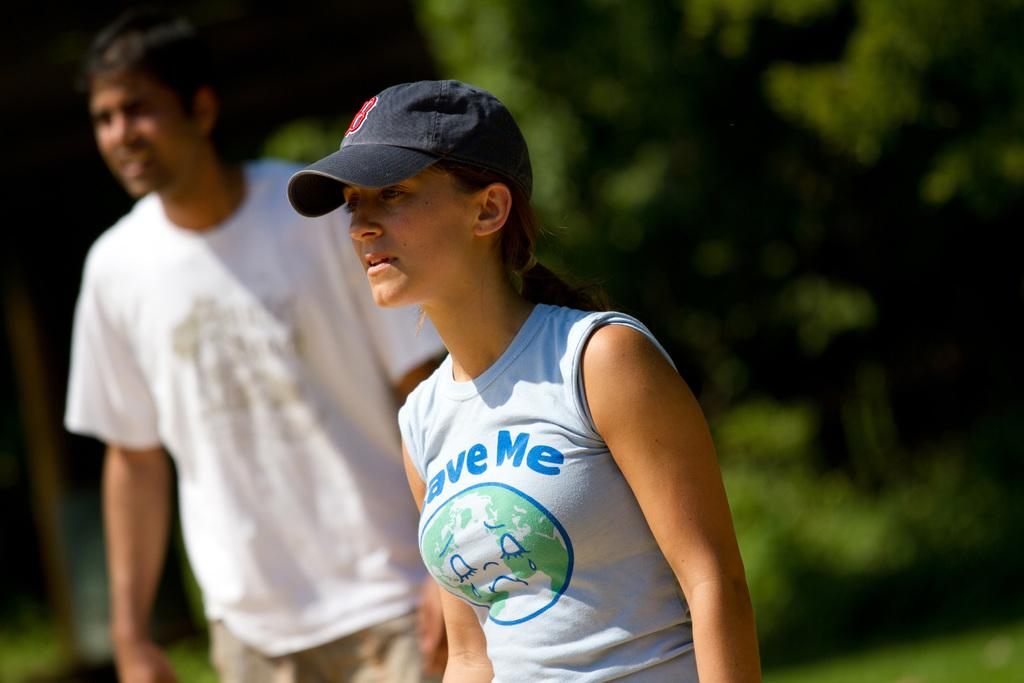<image>
Write a terse but informative summary of the picture. A woman wears a shirt that reads "save me" a message about the planet. 